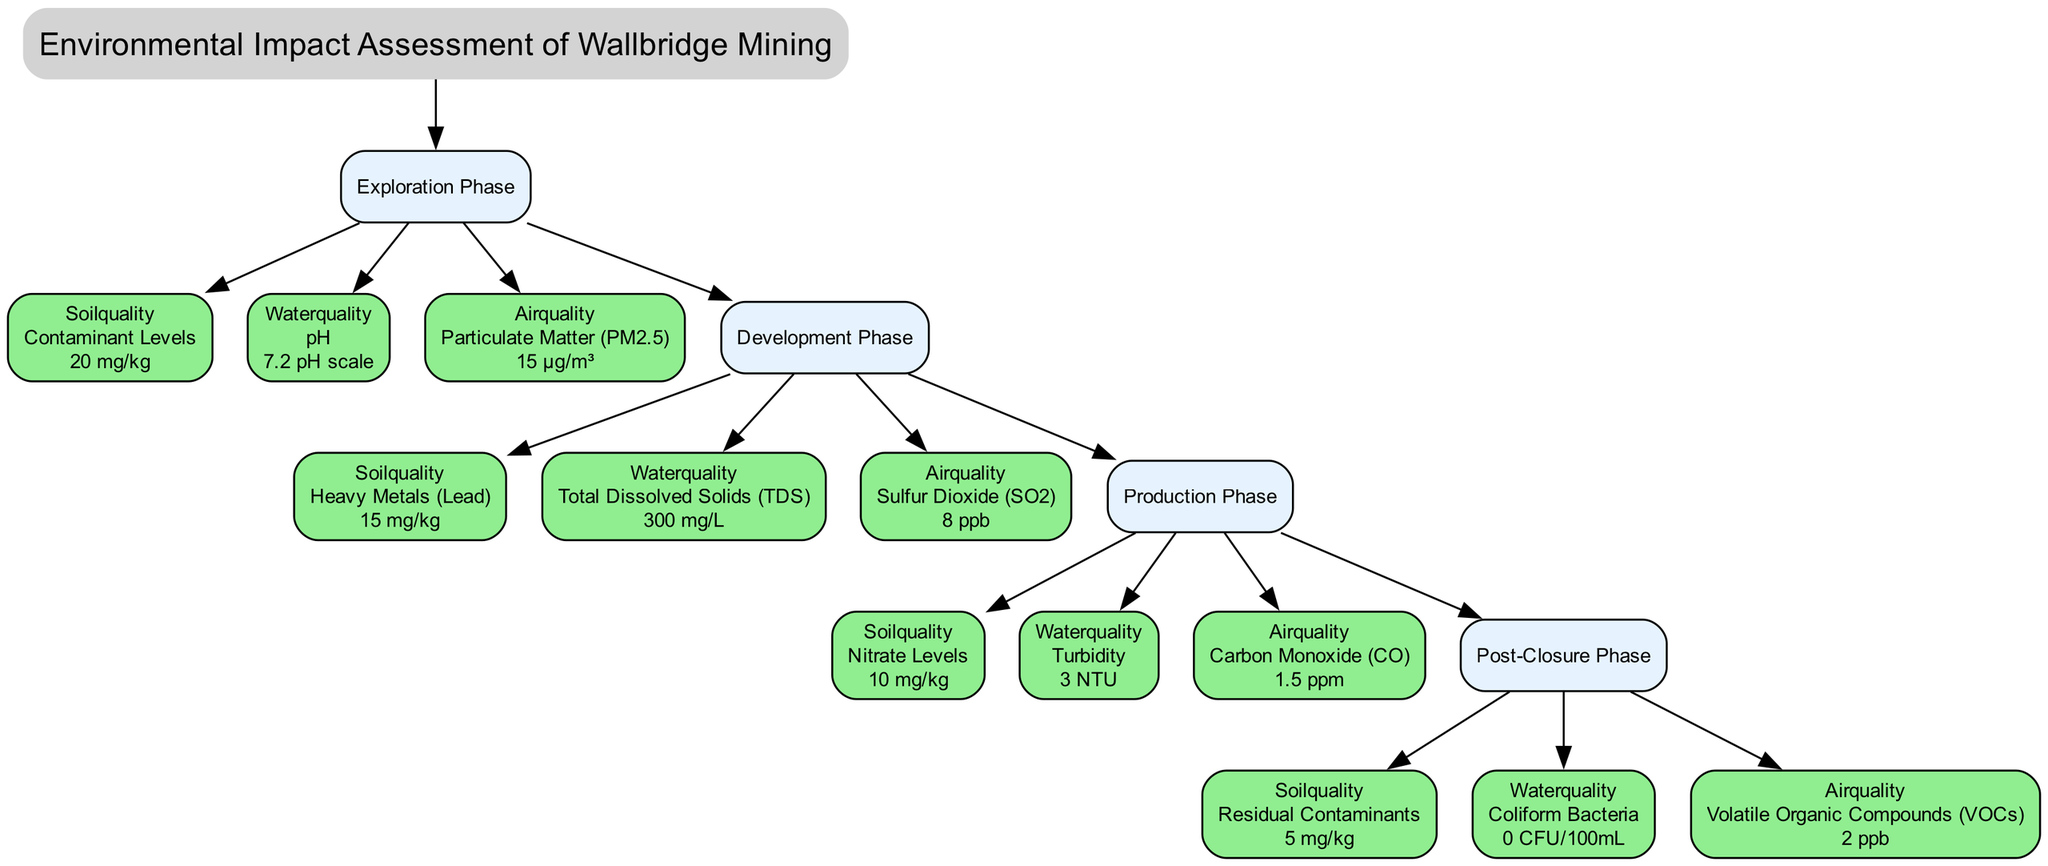What is the current reading of soil quality for the Exploration Phase? The diagram indicates that the soil quality parameter for the Exploration Phase is "Contaminant Levels," with a current reading of 20 mg/kg.
Answer: 20 mg/kg How many phases are included in the Environmental Impact Assessment? The diagram details four distinct phases: Exploration, Development, Production, and Post-Closure. Thus, a total of four phases are covered.
Answer: 4 What is the safe threshold for air quality during the Development Phase? The air quality parameter at the Development Phase is "Sulfur Dioxide," with a current reading of 8 ppb. The safe threshold for this parameter is 75 ppb, which can be found on the corresponding node for air quality in the Development Phase.
Answer: 75 ppb What is the current reading of water quality for the Production Phase? The diagram specifies that the water quality parameter for the Production Phase is "Turbidity," with a current reading of 3 NTU as indicated in the water quality node for that phase.
Answer: 3 NTU Which phase has the highest current reading for soil quality? By comparing all soil quality readings: 20 mg/kg (Exploration), 15 mg/kg (Development), 10 mg/kg (Production), and 5 mg/kg (Post-Closure), the Exploration Phase has the highest current reading at 20 mg/kg.
Answer: Exploration Phase Is the water quality current reading in the Post-Closure Phase within the safe threshold? The water quality parameter for the Post-Closure Phase is "Coliform Bacteria," with a current reading of 0 CFU/100mL. The safe threshold for this metric is 1 CFU/100mL. Since 0 is less than 1, it is within the safe threshold.
Answer: Yes What is the maximum safe threshold for Soil Quality in any of the phases? Reviewing the safe thresholds across all phases: 25 mg/kg (Exploration), 20 mg/kg (Development), 15 mg/kg (Production), and 10 mg/kg (Post-Closure), the maximum safe threshold is 25 mg/kg from the Exploration Phase.
Answer: 25 mg/kg Which monitoring category has the lowest current reading in the Development Phase? In the Development Phase, we check the current readings: Soil Quality has 15 mg/kg (Heavy Metals), Water Quality has 300 mg/L (Total Dissolved Solids), and Air Quality has 8 ppb (Sulfur Dioxide). The lowest among them is 15 mg/kg for Soil Quality.
Answer: 15 mg/kg 